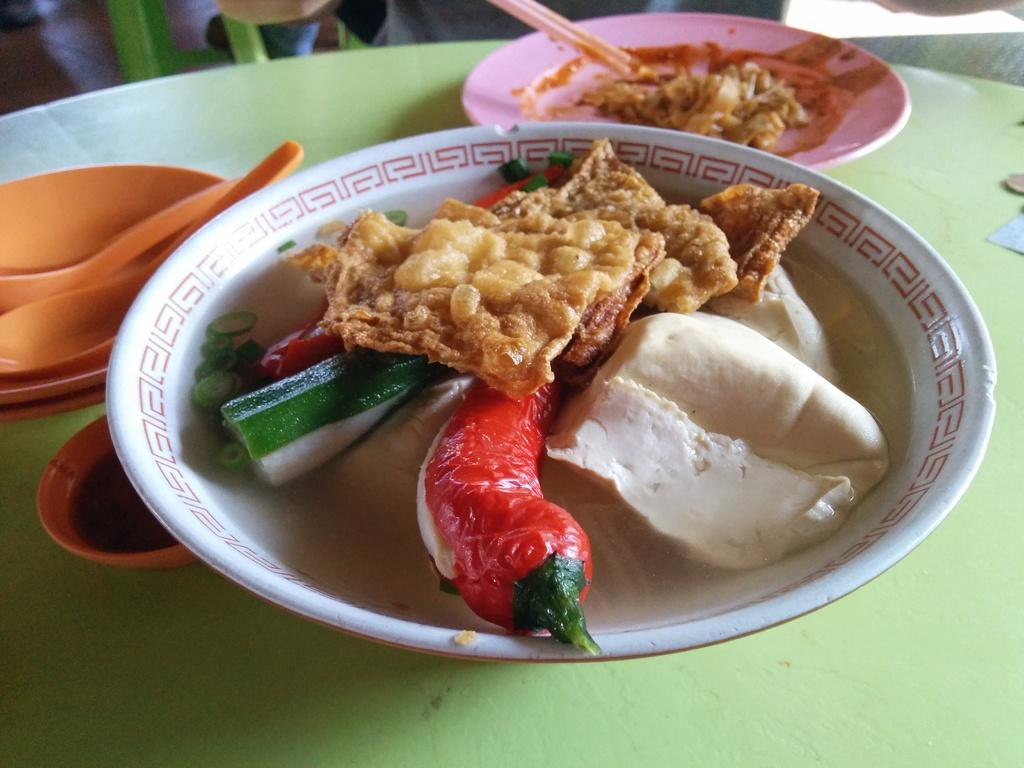What is on the plates in the image? There is food in the plates in the image. What else is present on the table besides the plates? There are bowls beside the plates in the image, and spoons are also present. Can you describe any other items on the table? There are other things on the table in the image, but their specific nature is not mentioned in the provided facts. How many birds are nesting in the room in the image? There is no mention of birds or a room in the provided facts, so it cannot be determined if any birds are nesting in the image. 